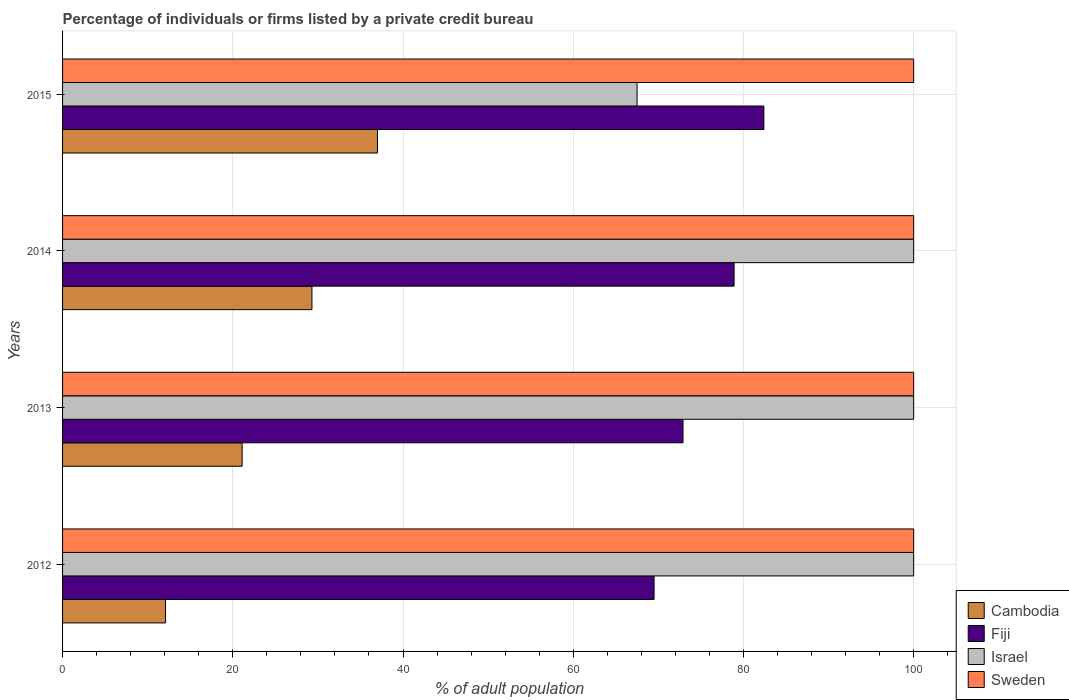How many groups of bars are there?
Ensure brevity in your answer.  4. Are the number of bars on each tick of the Y-axis equal?
Provide a short and direct response. Yes. How many bars are there on the 2nd tick from the top?
Your answer should be very brief. 4. Across all years, what is the maximum percentage of population listed by a private credit bureau in Israel?
Give a very brief answer. 100. Across all years, what is the minimum percentage of population listed by a private credit bureau in Fiji?
Your answer should be very brief. 69.5. In which year was the percentage of population listed by a private credit bureau in Fiji minimum?
Keep it short and to the point. 2012. What is the total percentage of population listed by a private credit bureau in Sweden in the graph?
Your answer should be compact. 400. What is the difference between the percentage of population listed by a private credit bureau in Sweden in 2014 and that in 2015?
Your answer should be very brief. 0. What is the difference between the percentage of population listed by a private credit bureau in Sweden in 2013 and the percentage of population listed by a private credit bureau in Fiji in 2012?
Ensure brevity in your answer.  30.5. What is the average percentage of population listed by a private credit bureau in Cambodia per year?
Keep it short and to the point. 24.88. In the year 2015, what is the difference between the percentage of population listed by a private credit bureau in Sweden and percentage of population listed by a private credit bureau in Fiji?
Give a very brief answer. 17.6. Is the percentage of population listed by a private credit bureau in Cambodia in 2013 less than that in 2014?
Provide a succinct answer. Yes. What is the difference between the highest and the lowest percentage of population listed by a private credit bureau in Fiji?
Offer a very short reply. 12.9. Is the sum of the percentage of population listed by a private credit bureau in Fiji in 2012 and 2015 greater than the maximum percentage of population listed by a private credit bureau in Cambodia across all years?
Offer a very short reply. Yes. Is it the case that in every year, the sum of the percentage of population listed by a private credit bureau in Sweden and percentage of population listed by a private credit bureau in Israel is greater than the sum of percentage of population listed by a private credit bureau in Cambodia and percentage of population listed by a private credit bureau in Fiji?
Keep it short and to the point. Yes. What does the 3rd bar from the top in 2014 represents?
Ensure brevity in your answer.  Fiji. What does the 2nd bar from the bottom in 2013 represents?
Make the answer very short. Fiji. Is it the case that in every year, the sum of the percentage of population listed by a private credit bureau in Cambodia and percentage of population listed by a private credit bureau in Fiji is greater than the percentage of population listed by a private credit bureau in Israel?
Your answer should be compact. No. Are all the bars in the graph horizontal?
Offer a terse response. Yes. Are the values on the major ticks of X-axis written in scientific E-notation?
Ensure brevity in your answer.  No. How many legend labels are there?
Keep it short and to the point. 4. What is the title of the graph?
Offer a terse response. Percentage of individuals or firms listed by a private credit bureau. What is the label or title of the X-axis?
Your response must be concise. % of adult population. What is the % of adult population of Cambodia in 2012?
Your answer should be compact. 12.1. What is the % of adult population in Fiji in 2012?
Provide a short and direct response. 69.5. What is the % of adult population in Israel in 2012?
Your response must be concise. 100. What is the % of adult population in Cambodia in 2013?
Keep it short and to the point. 21.1. What is the % of adult population in Fiji in 2013?
Keep it short and to the point. 72.9. What is the % of adult population in Israel in 2013?
Provide a short and direct response. 100. What is the % of adult population of Sweden in 2013?
Keep it short and to the point. 100. What is the % of adult population in Cambodia in 2014?
Provide a short and direct response. 29.3. What is the % of adult population of Fiji in 2014?
Keep it short and to the point. 78.9. What is the % of adult population of Israel in 2014?
Provide a succinct answer. 100. What is the % of adult population in Fiji in 2015?
Make the answer very short. 82.4. What is the % of adult population of Israel in 2015?
Your response must be concise. 67.5. Across all years, what is the maximum % of adult population of Fiji?
Offer a terse response. 82.4. Across all years, what is the maximum % of adult population in Israel?
Provide a short and direct response. 100. Across all years, what is the minimum % of adult population of Cambodia?
Your response must be concise. 12.1. Across all years, what is the minimum % of adult population of Fiji?
Offer a very short reply. 69.5. Across all years, what is the minimum % of adult population of Israel?
Make the answer very short. 67.5. What is the total % of adult population of Cambodia in the graph?
Your response must be concise. 99.5. What is the total % of adult population of Fiji in the graph?
Make the answer very short. 303.7. What is the total % of adult population in Israel in the graph?
Your answer should be compact. 367.5. What is the difference between the % of adult population of Cambodia in 2012 and that in 2013?
Keep it short and to the point. -9. What is the difference between the % of adult population of Sweden in 2012 and that in 2013?
Offer a terse response. 0. What is the difference between the % of adult population of Cambodia in 2012 and that in 2014?
Provide a succinct answer. -17.2. What is the difference between the % of adult population in Israel in 2012 and that in 2014?
Keep it short and to the point. 0. What is the difference between the % of adult population of Sweden in 2012 and that in 2014?
Your response must be concise. 0. What is the difference between the % of adult population of Cambodia in 2012 and that in 2015?
Offer a terse response. -24.9. What is the difference between the % of adult population of Fiji in 2012 and that in 2015?
Your answer should be compact. -12.9. What is the difference between the % of adult population in Israel in 2012 and that in 2015?
Ensure brevity in your answer.  32.5. What is the difference between the % of adult population in Fiji in 2013 and that in 2014?
Give a very brief answer. -6. What is the difference between the % of adult population in Israel in 2013 and that in 2014?
Provide a succinct answer. 0. What is the difference between the % of adult population of Sweden in 2013 and that in 2014?
Keep it short and to the point. 0. What is the difference between the % of adult population of Cambodia in 2013 and that in 2015?
Offer a terse response. -15.9. What is the difference between the % of adult population in Fiji in 2013 and that in 2015?
Your answer should be very brief. -9.5. What is the difference between the % of adult population of Israel in 2013 and that in 2015?
Make the answer very short. 32.5. What is the difference between the % of adult population in Sweden in 2013 and that in 2015?
Provide a succinct answer. 0. What is the difference between the % of adult population in Fiji in 2014 and that in 2015?
Your response must be concise. -3.5. What is the difference between the % of adult population of Israel in 2014 and that in 2015?
Make the answer very short. 32.5. What is the difference between the % of adult population of Sweden in 2014 and that in 2015?
Keep it short and to the point. 0. What is the difference between the % of adult population in Cambodia in 2012 and the % of adult population in Fiji in 2013?
Give a very brief answer. -60.8. What is the difference between the % of adult population in Cambodia in 2012 and the % of adult population in Israel in 2013?
Keep it short and to the point. -87.9. What is the difference between the % of adult population of Cambodia in 2012 and the % of adult population of Sweden in 2013?
Make the answer very short. -87.9. What is the difference between the % of adult population in Fiji in 2012 and the % of adult population in Israel in 2013?
Offer a terse response. -30.5. What is the difference between the % of adult population in Fiji in 2012 and the % of adult population in Sweden in 2013?
Provide a short and direct response. -30.5. What is the difference between the % of adult population in Israel in 2012 and the % of adult population in Sweden in 2013?
Your response must be concise. 0. What is the difference between the % of adult population in Cambodia in 2012 and the % of adult population in Fiji in 2014?
Ensure brevity in your answer.  -66.8. What is the difference between the % of adult population in Cambodia in 2012 and the % of adult population in Israel in 2014?
Your answer should be compact. -87.9. What is the difference between the % of adult population of Cambodia in 2012 and the % of adult population of Sweden in 2014?
Offer a terse response. -87.9. What is the difference between the % of adult population of Fiji in 2012 and the % of adult population of Israel in 2014?
Your answer should be compact. -30.5. What is the difference between the % of adult population in Fiji in 2012 and the % of adult population in Sweden in 2014?
Make the answer very short. -30.5. What is the difference between the % of adult population in Israel in 2012 and the % of adult population in Sweden in 2014?
Your answer should be compact. 0. What is the difference between the % of adult population in Cambodia in 2012 and the % of adult population in Fiji in 2015?
Provide a short and direct response. -70.3. What is the difference between the % of adult population of Cambodia in 2012 and the % of adult population of Israel in 2015?
Keep it short and to the point. -55.4. What is the difference between the % of adult population of Cambodia in 2012 and the % of adult population of Sweden in 2015?
Give a very brief answer. -87.9. What is the difference between the % of adult population of Fiji in 2012 and the % of adult population of Sweden in 2015?
Your answer should be very brief. -30.5. What is the difference between the % of adult population in Israel in 2012 and the % of adult population in Sweden in 2015?
Offer a very short reply. 0. What is the difference between the % of adult population of Cambodia in 2013 and the % of adult population of Fiji in 2014?
Offer a very short reply. -57.8. What is the difference between the % of adult population in Cambodia in 2013 and the % of adult population in Israel in 2014?
Your answer should be very brief. -78.9. What is the difference between the % of adult population in Cambodia in 2013 and the % of adult population in Sweden in 2014?
Your answer should be very brief. -78.9. What is the difference between the % of adult population of Fiji in 2013 and the % of adult population of Israel in 2014?
Keep it short and to the point. -27.1. What is the difference between the % of adult population of Fiji in 2013 and the % of adult population of Sweden in 2014?
Provide a succinct answer. -27.1. What is the difference between the % of adult population of Cambodia in 2013 and the % of adult population of Fiji in 2015?
Your response must be concise. -61.3. What is the difference between the % of adult population in Cambodia in 2013 and the % of adult population in Israel in 2015?
Give a very brief answer. -46.4. What is the difference between the % of adult population of Cambodia in 2013 and the % of adult population of Sweden in 2015?
Make the answer very short. -78.9. What is the difference between the % of adult population in Fiji in 2013 and the % of adult population in Sweden in 2015?
Provide a short and direct response. -27.1. What is the difference between the % of adult population of Cambodia in 2014 and the % of adult population of Fiji in 2015?
Make the answer very short. -53.1. What is the difference between the % of adult population in Cambodia in 2014 and the % of adult population in Israel in 2015?
Ensure brevity in your answer.  -38.2. What is the difference between the % of adult population in Cambodia in 2014 and the % of adult population in Sweden in 2015?
Provide a succinct answer. -70.7. What is the difference between the % of adult population of Fiji in 2014 and the % of adult population of Sweden in 2015?
Offer a terse response. -21.1. What is the average % of adult population of Cambodia per year?
Provide a short and direct response. 24.88. What is the average % of adult population in Fiji per year?
Your answer should be very brief. 75.92. What is the average % of adult population in Israel per year?
Ensure brevity in your answer.  91.88. What is the average % of adult population in Sweden per year?
Offer a terse response. 100. In the year 2012, what is the difference between the % of adult population in Cambodia and % of adult population in Fiji?
Your answer should be compact. -57.4. In the year 2012, what is the difference between the % of adult population in Cambodia and % of adult population in Israel?
Offer a terse response. -87.9. In the year 2012, what is the difference between the % of adult population of Cambodia and % of adult population of Sweden?
Give a very brief answer. -87.9. In the year 2012, what is the difference between the % of adult population of Fiji and % of adult population of Israel?
Give a very brief answer. -30.5. In the year 2012, what is the difference between the % of adult population in Fiji and % of adult population in Sweden?
Keep it short and to the point. -30.5. In the year 2013, what is the difference between the % of adult population of Cambodia and % of adult population of Fiji?
Ensure brevity in your answer.  -51.8. In the year 2013, what is the difference between the % of adult population in Cambodia and % of adult population in Israel?
Make the answer very short. -78.9. In the year 2013, what is the difference between the % of adult population of Cambodia and % of adult population of Sweden?
Your response must be concise. -78.9. In the year 2013, what is the difference between the % of adult population of Fiji and % of adult population of Israel?
Your response must be concise. -27.1. In the year 2013, what is the difference between the % of adult population of Fiji and % of adult population of Sweden?
Provide a short and direct response. -27.1. In the year 2014, what is the difference between the % of adult population in Cambodia and % of adult population in Fiji?
Make the answer very short. -49.6. In the year 2014, what is the difference between the % of adult population in Cambodia and % of adult population in Israel?
Provide a short and direct response. -70.7. In the year 2014, what is the difference between the % of adult population in Cambodia and % of adult population in Sweden?
Keep it short and to the point. -70.7. In the year 2014, what is the difference between the % of adult population of Fiji and % of adult population of Israel?
Your response must be concise. -21.1. In the year 2014, what is the difference between the % of adult population of Fiji and % of adult population of Sweden?
Give a very brief answer. -21.1. In the year 2015, what is the difference between the % of adult population of Cambodia and % of adult population of Fiji?
Offer a terse response. -45.4. In the year 2015, what is the difference between the % of adult population in Cambodia and % of adult population in Israel?
Offer a very short reply. -30.5. In the year 2015, what is the difference between the % of adult population of Cambodia and % of adult population of Sweden?
Your answer should be very brief. -63. In the year 2015, what is the difference between the % of adult population in Fiji and % of adult population in Israel?
Give a very brief answer. 14.9. In the year 2015, what is the difference between the % of adult population in Fiji and % of adult population in Sweden?
Your response must be concise. -17.6. In the year 2015, what is the difference between the % of adult population in Israel and % of adult population in Sweden?
Offer a terse response. -32.5. What is the ratio of the % of adult population in Cambodia in 2012 to that in 2013?
Your answer should be compact. 0.57. What is the ratio of the % of adult population of Fiji in 2012 to that in 2013?
Provide a short and direct response. 0.95. What is the ratio of the % of adult population in Israel in 2012 to that in 2013?
Your answer should be compact. 1. What is the ratio of the % of adult population in Cambodia in 2012 to that in 2014?
Give a very brief answer. 0.41. What is the ratio of the % of adult population of Fiji in 2012 to that in 2014?
Offer a very short reply. 0.88. What is the ratio of the % of adult population in Israel in 2012 to that in 2014?
Provide a succinct answer. 1. What is the ratio of the % of adult population of Sweden in 2012 to that in 2014?
Provide a succinct answer. 1. What is the ratio of the % of adult population in Cambodia in 2012 to that in 2015?
Provide a succinct answer. 0.33. What is the ratio of the % of adult population in Fiji in 2012 to that in 2015?
Offer a terse response. 0.84. What is the ratio of the % of adult population of Israel in 2012 to that in 2015?
Keep it short and to the point. 1.48. What is the ratio of the % of adult population in Sweden in 2012 to that in 2015?
Ensure brevity in your answer.  1. What is the ratio of the % of adult population of Cambodia in 2013 to that in 2014?
Give a very brief answer. 0.72. What is the ratio of the % of adult population in Fiji in 2013 to that in 2014?
Give a very brief answer. 0.92. What is the ratio of the % of adult population in Sweden in 2013 to that in 2014?
Make the answer very short. 1. What is the ratio of the % of adult population in Cambodia in 2013 to that in 2015?
Your response must be concise. 0.57. What is the ratio of the % of adult population of Fiji in 2013 to that in 2015?
Offer a very short reply. 0.88. What is the ratio of the % of adult population of Israel in 2013 to that in 2015?
Provide a succinct answer. 1.48. What is the ratio of the % of adult population of Sweden in 2013 to that in 2015?
Your answer should be very brief. 1. What is the ratio of the % of adult population in Cambodia in 2014 to that in 2015?
Provide a succinct answer. 0.79. What is the ratio of the % of adult population in Fiji in 2014 to that in 2015?
Provide a succinct answer. 0.96. What is the ratio of the % of adult population of Israel in 2014 to that in 2015?
Keep it short and to the point. 1.48. What is the ratio of the % of adult population of Sweden in 2014 to that in 2015?
Give a very brief answer. 1. What is the difference between the highest and the second highest % of adult population in Sweden?
Provide a succinct answer. 0. What is the difference between the highest and the lowest % of adult population of Cambodia?
Keep it short and to the point. 24.9. What is the difference between the highest and the lowest % of adult population of Israel?
Keep it short and to the point. 32.5. What is the difference between the highest and the lowest % of adult population of Sweden?
Provide a succinct answer. 0. 